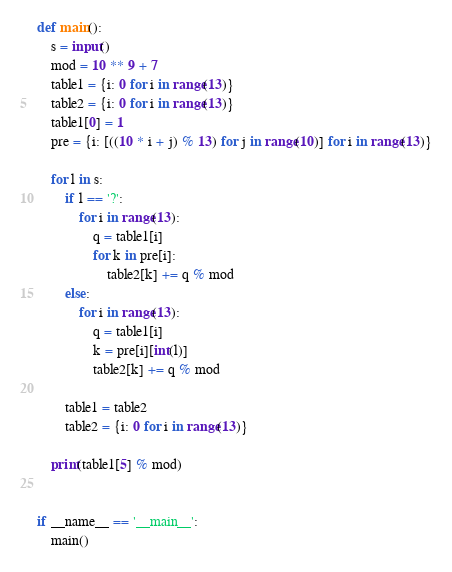Convert code to text. <code><loc_0><loc_0><loc_500><loc_500><_Python_>def main():
    s = input()
    mod = 10 ** 9 + 7
    table1 = {i: 0 for i in range(13)}
    table2 = {i: 0 for i in range(13)}
    table1[0] = 1
    pre = {i: [((10 * i + j) % 13) for j in range(10)] for i in range(13)}

    for l in s:
        if l == '?':
            for i in range(13):
                q = table1[i]
                for k in pre[i]:
                    table2[k] += q % mod
        else:
            for i in range(13):
                q = table1[i]
                k = pre[i][int(l)]
                table2[k] += q % mod

        table1 = table2
        table2 = {i: 0 for i in range(13)}

    print(table1[5] % mod)


if __name__ == '__main__':
    main()
</code> 